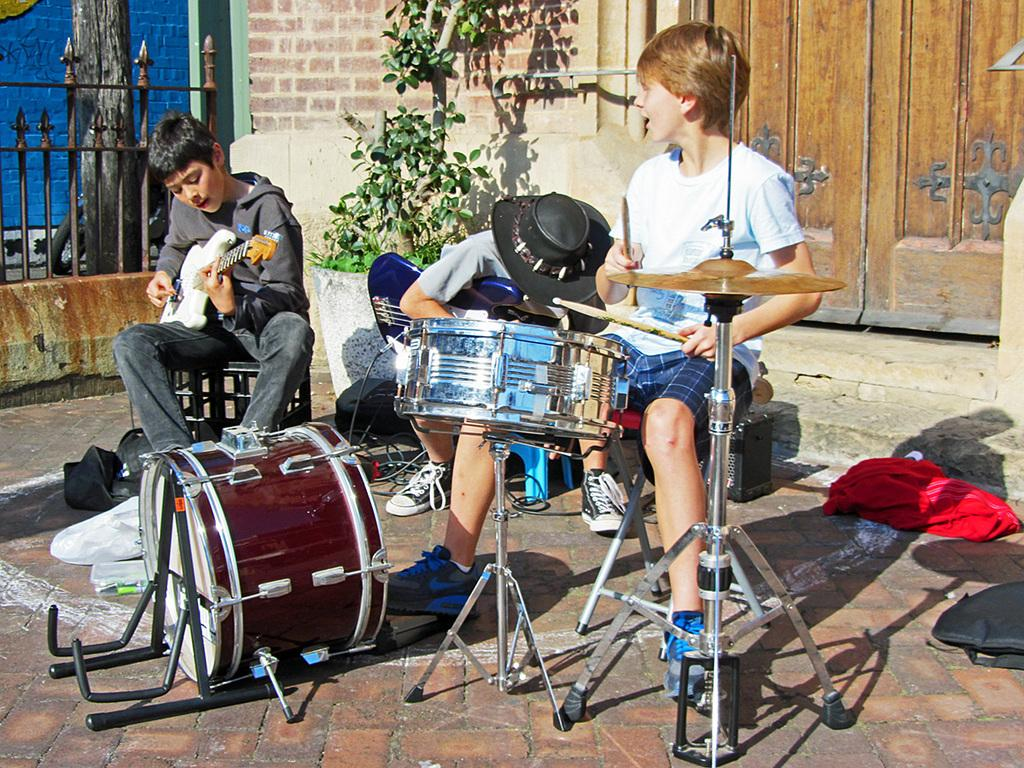Where is the setting of the image? The image is outside of the city. How many boys are in the image? There are three boys in the image. What are the boys doing in the image? The boys are sitting on chairs and playing musical instruments. What can be seen in the background of the image? There is a closed door, a plant, and a flower pot in the background of the image. What type of division is being taught to the boys in the image? There is no indication in the image that the boys are being taught any division or subject matter. Do the boys have tails in the image? There is no indication in the image that the boys have tails or any non-human features. 